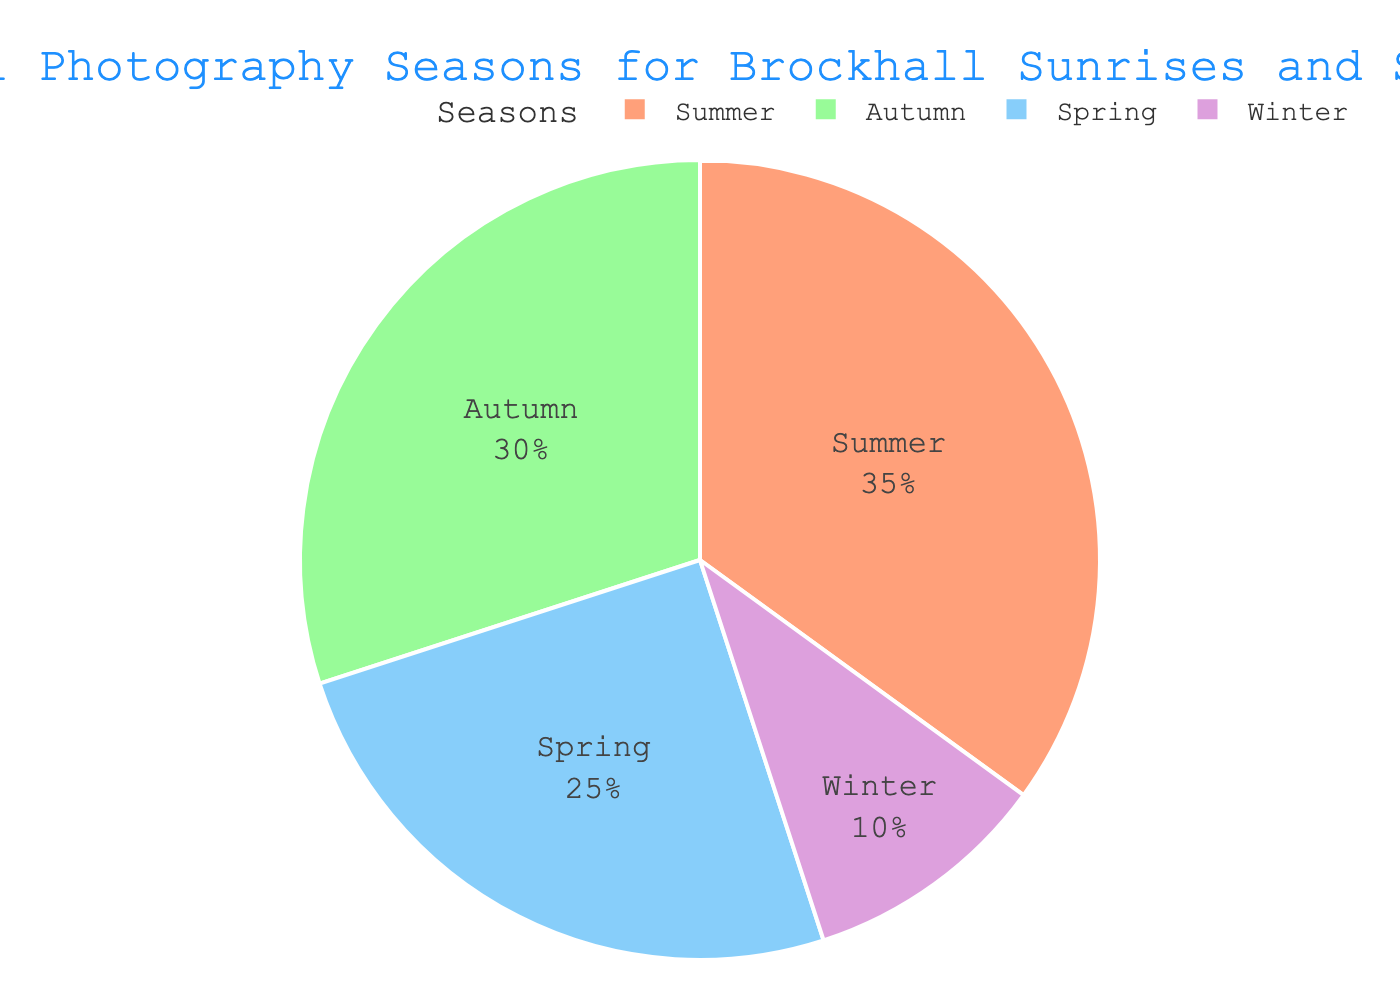What season represents the largest portion of the optimal photography times? The largest segment of the pie chart is labeled "Summer." By comparing the size of the segments, it is clear that Summer has the largest portion.
Answer: Summer What is the total percentage of optimal photography times for Spring and Autumn combined? The pie chart shows that Spring is 25% and Autumn is 30%. Adding these two together gives 25% + 30% = 55%.
Answer: 55% By how much does Summer exceed Winter in terms of optimal photography times? From the pie chart, Summer is 35% and Winter is 10%. The difference is calculated as 35% - 10% = 25%.
Answer: 25% Which season is the least optimal for photography according to the chart? The smallest segment in the pie chart corresponds to Winter, which is labeled as 10%.
Answer: Winter If Spring and Winter were combined, would they exceed the portion for Autumn? Spring is 25% and Winter is 10%. Combining these two percentages gives 25% + 10% = 35%, which is equal to the percentage for Autumn.
Answer: Yes, they would be equal What is the ratio of the optimal photography times between the most and least favorable seasons? The most favorable season is Summer at 35%, and the least favorable is Winter at 10%. The ratio is 35% to 10%, which simplifies to 3.5:1.
Answer: 3.5:1 Compare the optimal photography times between Autumn and Spring. Which is higher and by how much? Autumn has 30% while Spring has 25%. The difference is 30% - 25% = 5%, so Autumn is higher by 5%.
Answer: Autumn is higher by 5% What fraction of the year is considered optimal for photography in Autumn? Autumn occupies 30% of the pie chart, which means it represents 30/100 = 3/10 or 0.3 of the year.
Answer: 3/10 Determine the average percentage of the two most optimal seasons. The two most optimal seasons are Summer (35%) and Autumn (30%). The average is calculated as (35% + 30%) / 2 = 65% / 2 = 32.5%.
Answer: 32.5% 